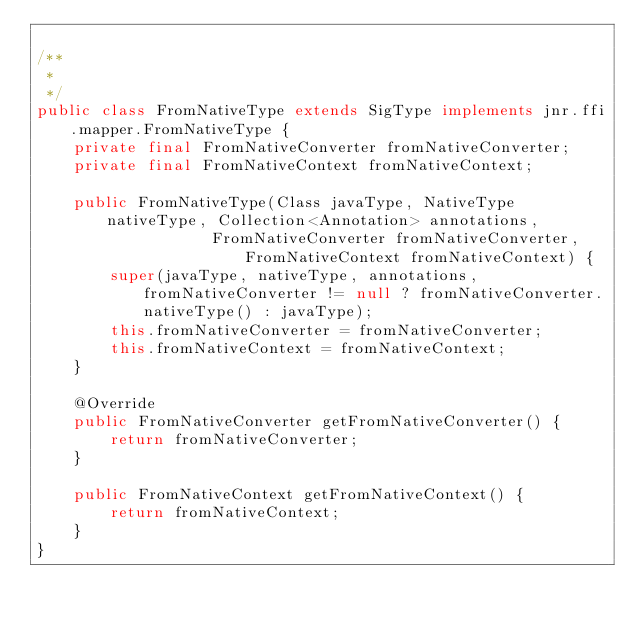Convert code to text. <code><loc_0><loc_0><loc_500><loc_500><_Java_>
/**
 *
 */
public class FromNativeType extends SigType implements jnr.ffi.mapper.FromNativeType {
    private final FromNativeConverter fromNativeConverter;
    private final FromNativeContext fromNativeContext;

    public FromNativeType(Class javaType, NativeType nativeType, Collection<Annotation> annotations,
                   FromNativeConverter fromNativeConverter, FromNativeContext fromNativeContext) {
        super(javaType, nativeType, annotations, fromNativeConverter != null ? fromNativeConverter.nativeType() : javaType);
        this.fromNativeConverter = fromNativeConverter;
        this.fromNativeContext = fromNativeContext;
    }

    @Override
    public FromNativeConverter getFromNativeConverter() {
        return fromNativeConverter;
    }

    public FromNativeContext getFromNativeContext() {
        return fromNativeContext;
    }
}
</code> 